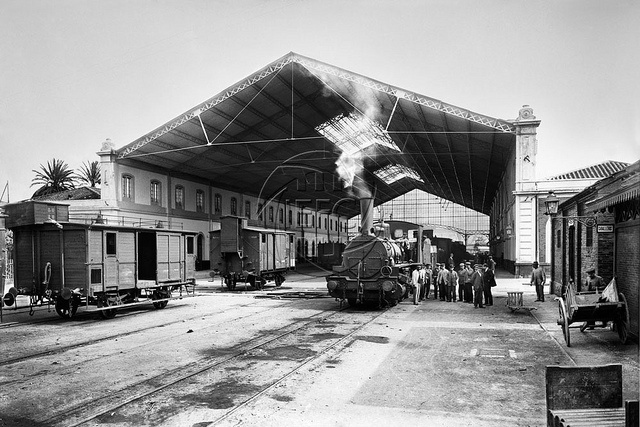Describe the objects in this image and their specific colors. I can see train in lightgray, black, darkgray, and gray tones, train in lightgray, black, gray, darkgray, and gainsboro tones, train in lightgray, black, gray, and darkgray tones, people in lightgray, black, gray, and darkgray tones, and people in lightgray, black, gray, darkgray, and white tones in this image. 